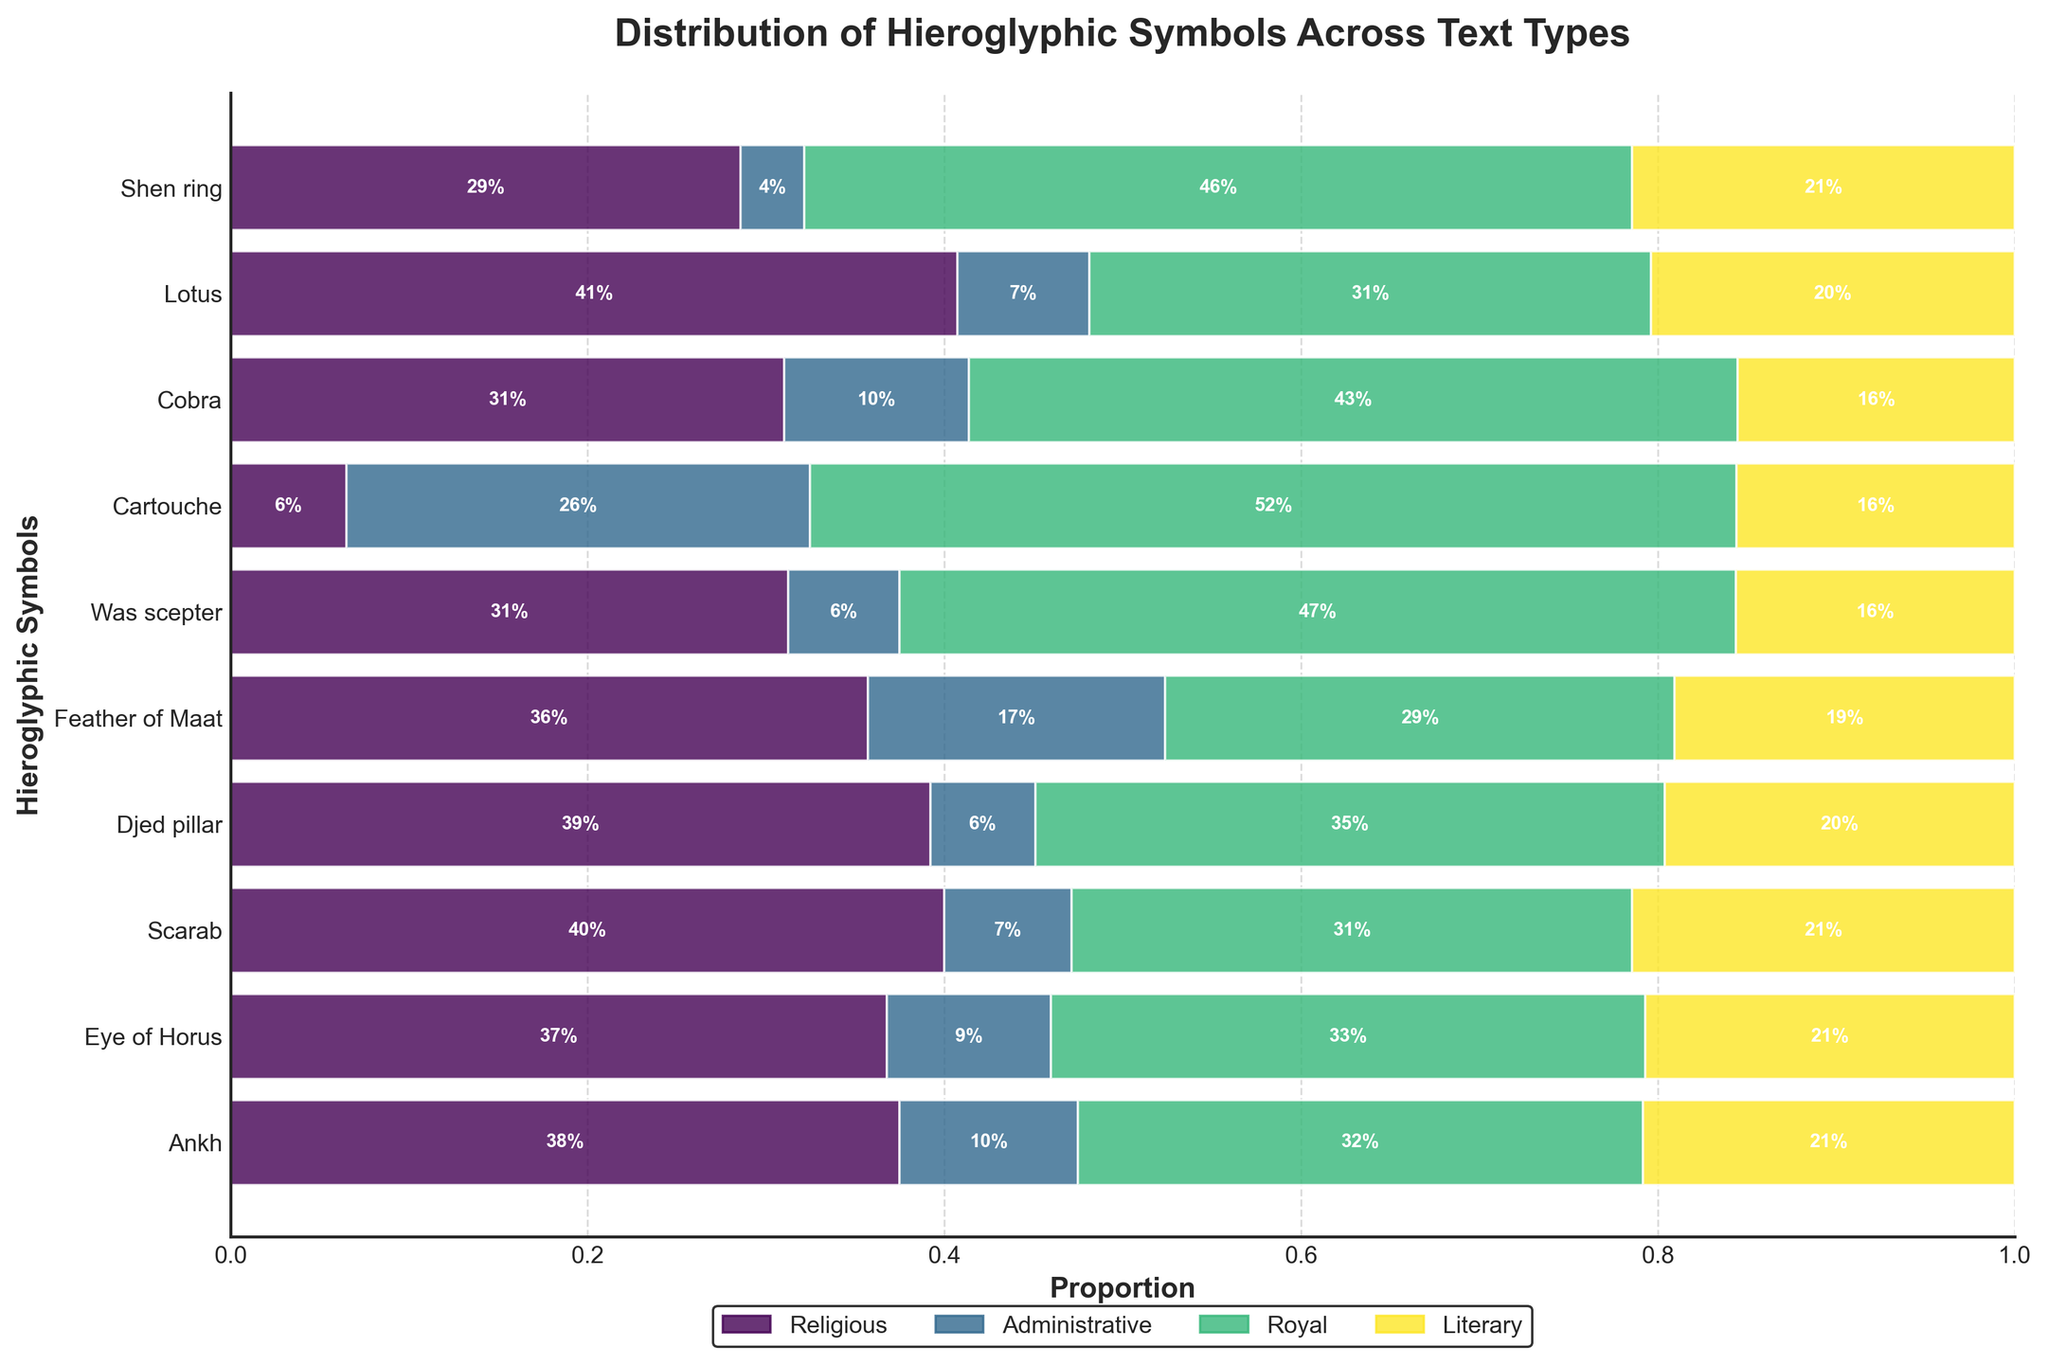What's the title of the figure? The title is usually found at the top of the plot. In this case, it reads "Distribution of Hieroglyphic Symbols Across Text Types."
Answer: Distribution of Hieroglyphic Symbols Across Text Types Which hieroglyphic symbol appears most frequently in Royal texts? To determine this, look at the height of the bars for each hieroglyphic symbol in the Royal category. The symbol with the tallest bar is Cartouche.
Answer: Cartouche How do the proportions of the Ankh symbol differ between Religious and Administrative texts? Observe the segment lengths of the Ankh row in the Religious and Administrative columns. The proportion in Religious texts is much larger than that in Administrative texts.
Answer: Much larger in Religious What is the combined proportion of the Ankh symbol used in Religious and Literary texts? Add the proportions of the Ankh symbol in Religious and Literary texts. From the plot, these proportions are 45% and 25% respectively, so 0.45 + 0.25 = 0.70 or 70%.
Answer: 70% Which type of text uses the Was scepter symbol the least? Look at the segments corresponding to the Was scepter across all text types. The Administrative text has the smallest bar segment for the Was scepter.
Answer: Administrative Compare the usage proportions of the Eye of Horus and Cobra symbols in Royal texts. Which symbol has the higher proportion? In the row for Royal texts, the segment for the Cobra symbol is taller than the segment for the Eye of Horus, indicating Cobra has a higher proportion in Royal texts.
Answer: Cobra Is there any hieroglyphic symbol that is used in all four types of texts with more than 15% proportion in any category? Check each row for symbols with any segment greater than 15%. Cartouche is the only symbol with segments above 15% in all columns (Administrative and Royal).
Answer: Cartouche Which hieroglyphic symbol has the highest proportion in Administrative texts, and what is the proportion? Check the height of the segments in the Administrative column. Cartouche has the highest segment, and the proportion is 20%.
Answer: Cartouche, 20% What is the general trend in the use of the Djed pillar symbol across the text types? The Djed pillar symbol appears to have higher proportions in Religious and Royal texts, while noticeably lower in Administrative and Literary texts.
Answer: Higher in Religious and Royal, lower in Administrative and Literary How does the usage of the Feather of Maat compare across Literary and Administrative texts? The Feather of Maat has a taller segment in Literary texts compared to Administrative texts, indicating it has a higher proportion in Literary texts.
Answer: Higher in Literary 